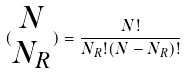Convert formula to latex. <formula><loc_0><loc_0><loc_500><loc_500>( \begin{matrix} N \\ N _ { R } \end{matrix} ) = \frac { N ! } { N _ { R } ! ( N - N _ { R } ) ! }</formula> 